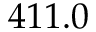Convert formula to latex. <formula><loc_0><loc_0><loc_500><loc_500>4 1 1 . 0</formula> 